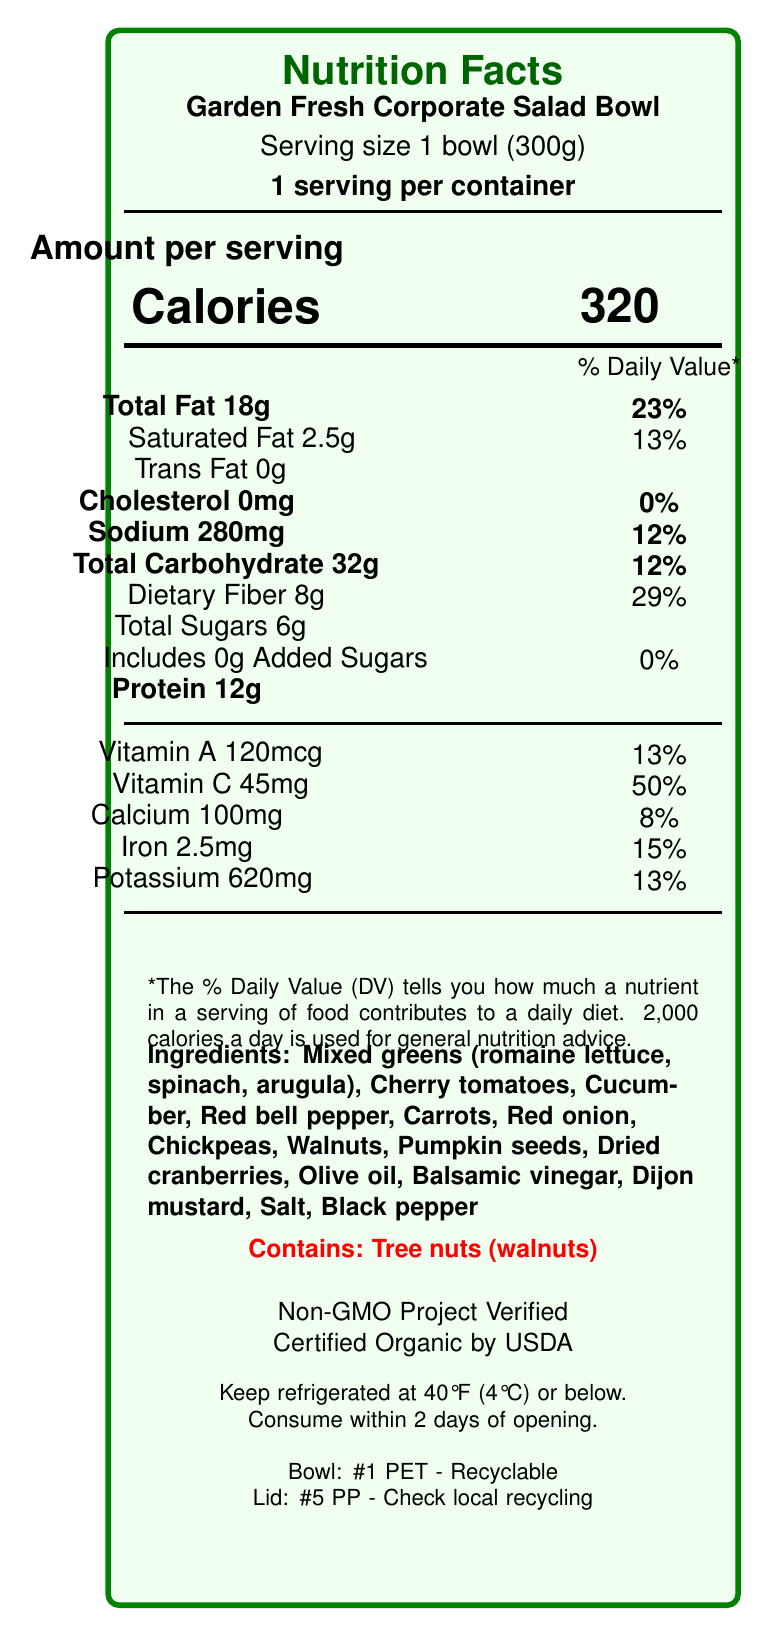what is the serving size of the Garden Fresh Corporate Salad Bowl? The serving size is listed at the top of the Nutrition Facts section: "Serving size 1 bowl (300g)".
Answer: 1 bowl (300g) how many calories are in one serving of the salad bowl? The calories per serving are specified in the "Amount per serving" section of the Nutrition Facts: "Calories 320".
Answer: 320 what is the total fat content per serving, and its percentage of the daily value? The total fat content and its daily value percentage are listed: "Total Fat 18g 23%".
Answer: 18g (23%) how many grams of dietary fiber does one serving contain? The dietary fiber content is listed in the "Total Carbohydrate" section: "Dietary Fiber 8g".
Answer: 8g is the salad bowl free from added sugars? The document states "Includes 0g Added Sugars", meaning there are no added sugars in the salad.
Answer: Yes what certifications does the Garden Fresh Corporate Salad Bowl have? A. Kosher B. Non-GMO C. USDA Organic D. All of the above The salad bowl is "Non-GMO Project Verified" and "Certified Organic by USDA".
Answer: B, C what is the percentage of daily value for iron provided by one serving? A. 8% B. 13% C. 15% D. 50% The document lists the daily value for iron as 15%: "Iron 2.5mg 15%".
Answer: C does the product contain any allergens? The document clearly states "Contains: Tree nuts (walnuts)".
Answer: Yes should the salad bowl be refrigerated? The storage instructions indicate "Keep refrigerated at 40°F (4°C) or below".
Answer: Yes are the bowls recyclable? The recycling information specifies: "Bowl: #1 PET - Recyclable".
Answer: Yes summarize the main nutritional benefits of the Garden Fresh Corporate Salad Bowl. The document highlights that the salad bowl is rich in essential nutrients, certified organic and non-GMO, and contains beneficial ingredients like mixed greens, chickpeas, and nuts. Its nutritional profile makes it a healthy option for consumers.
Answer: The Garden Fresh Corporate Salad Bowl is a nutritious meal option, providing heart-healthy fats from nuts and seeds, robust vegetable content, and significant daily value percentages of vitamins and minerals, including a good source of fiber, vitamin C, and iron. The product is Non-GMO and USDA Organic certified and free from cholesterol and added sugars. can we determine the expiration date of the salad bowl from the document? The document provides storage instructions but does not mention an expiration date.
Answer: Not enough information what is the facility's approach to food safety for this product? This information is included in the "foodSafetyInfo" and "qualityControlMeasures" sections of the document.
Answer: The facility follows HACCP principles and is FDA registered. The product undergoes batch testing for microbial contamination, metal detection screening, and cold chain management throughout production and distribution. 